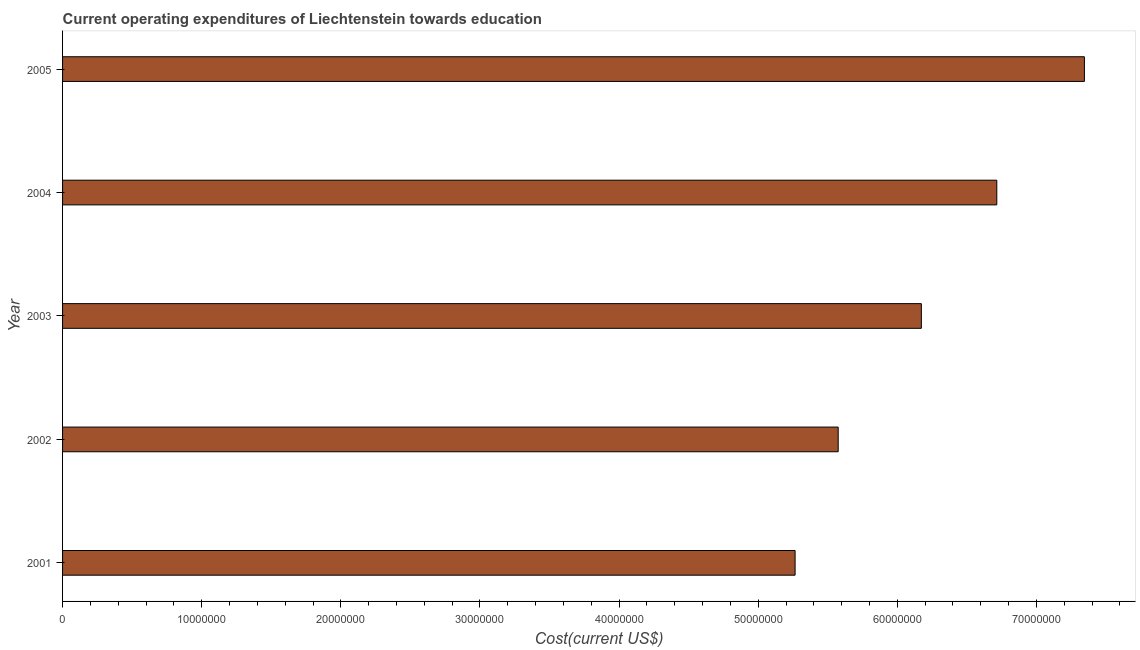Does the graph contain grids?
Provide a short and direct response. No. What is the title of the graph?
Ensure brevity in your answer.  Current operating expenditures of Liechtenstein towards education. What is the label or title of the X-axis?
Provide a succinct answer. Cost(current US$). What is the education expenditure in 2005?
Provide a succinct answer. 7.34e+07. Across all years, what is the maximum education expenditure?
Your answer should be compact. 7.34e+07. Across all years, what is the minimum education expenditure?
Make the answer very short. 5.27e+07. In which year was the education expenditure maximum?
Your response must be concise. 2005. What is the sum of the education expenditure?
Your answer should be very brief. 3.11e+08. What is the difference between the education expenditure in 2001 and 2003?
Your answer should be compact. -9.08e+06. What is the average education expenditure per year?
Keep it short and to the point. 6.21e+07. What is the median education expenditure?
Keep it short and to the point. 6.17e+07. What is the ratio of the education expenditure in 2001 to that in 2003?
Your answer should be compact. 0.85. Is the education expenditure in 2001 less than that in 2003?
Your response must be concise. Yes. Is the difference between the education expenditure in 2001 and 2004 greater than the difference between any two years?
Offer a terse response. No. What is the difference between the highest and the second highest education expenditure?
Your response must be concise. 6.30e+06. Is the sum of the education expenditure in 2004 and 2005 greater than the maximum education expenditure across all years?
Ensure brevity in your answer.  Yes. What is the difference between the highest and the lowest education expenditure?
Your answer should be compact. 2.08e+07. Are all the bars in the graph horizontal?
Offer a very short reply. Yes. How many years are there in the graph?
Ensure brevity in your answer.  5. What is the Cost(current US$) of 2001?
Offer a terse response. 5.27e+07. What is the Cost(current US$) of 2002?
Your answer should be very brief. 5.57e+07. What is the Cost(current US$) of 2003?
Provide a short and direct response. 6.17e+07. What is the Cost(current US$) of 2004?
Make the answer very short. 6.71e+07. What is the Cost(current US$) of 2005?
Keep it short and to the point. 7.34e+07. What is the difference between the Cost(current US$) in 2001 and 2002?
Your answer should be very brief. -3.10e+06. What is the difference between the Cost(current US$) in 2001 and 2003?
Provide a succinct answer. -9.08e+06. What is the difference between the Cost(current US$) in 2001 and 2004?
Your response must be concise. -1.45e+07. What is the difference between the Cost(current US$) in 2001 and 2005?
Ensure brevity in your answer.  -2.08e+07. What is the difference between the Cost(current US$) in 2002 and 2003?
Give a very brief answer. -5.98e+06. What is the difference between the Cost(current US$) in 2002 and 2004?
Your response must be concise. -1.14e+07. What is the difference between the Cost(current US$) in 2002 and 2005?
Make the answer very short. -1.77e+07. What is the difference between the Cost(current US$) in 2003 and 2004?
Offer a very short reply. -5.42e+06. What is the difference between the Cost(current US$) in 2003 and 2005?
Give a very brief answer. -1.17e+07. What is the difference between the Cost(current US$) in 2004 and 2005?
Provide a succinct answer. -6.30e+06. What is the ratio of the Cost(current US$) in 2001 to that in 2002?
Offer a terse response. 0.94. What is the ratio of the Cost(current US$) in 2001 to that in 2003?
Give a very brief answer. 0.85. What is the ratio of the Cost(current US$) in 2001 to that in 2004?
Your response must be concise. 0.78. What is the ratio of the Cost(current US$) in 2001 to that in 2005?
Give a very brief answer. 0.72. What is the ratio of the Cost(current US$) in 2002 to that in 2003?
Make the answer very short. 0.9. What is the ratio of the Cost(current US$) in 2002 to that in 2004?
Your response must be concise. 0.83. What is the ratio of the Cost(current US$) in 2002 to that in 2005?
Ensure brevity in your answer.  0.76. What is the ratio of the Cost(current US$) in 2003 to that in 2004?
Your answer should be compact. 0.92. What is the ratio of the Cost(current US$) in 2003 to that in 2005?
Keep it short and to the point. 0.84. What is the ratio of the Cost(current US$) in 2004 to that in 2005?
Provide a succinct answer. 0.91. 